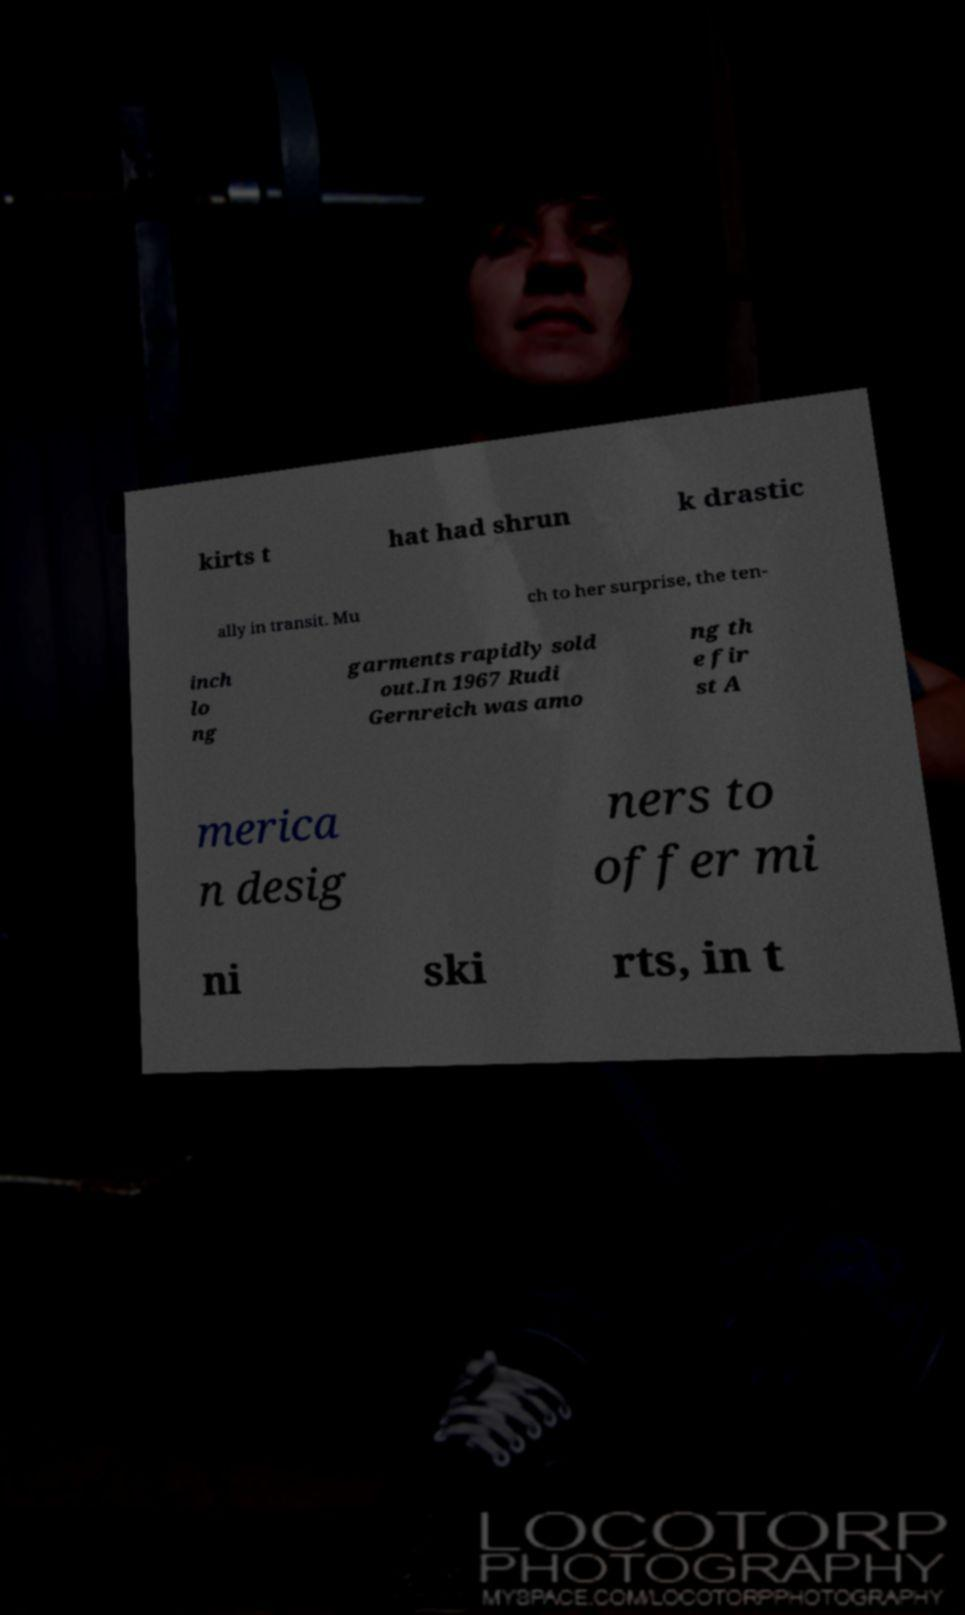I need the written content from this picture converted into text. Can you do that? kirts t hat had shrun k drastic ally in transit. Mu ch to her surprise, the ten- inch lo ng garments rapidly sold out.In 1967 Rudi Gernreich was amo ng th e fir st A merica n desig ners to offer mi ni ski rts, in t 